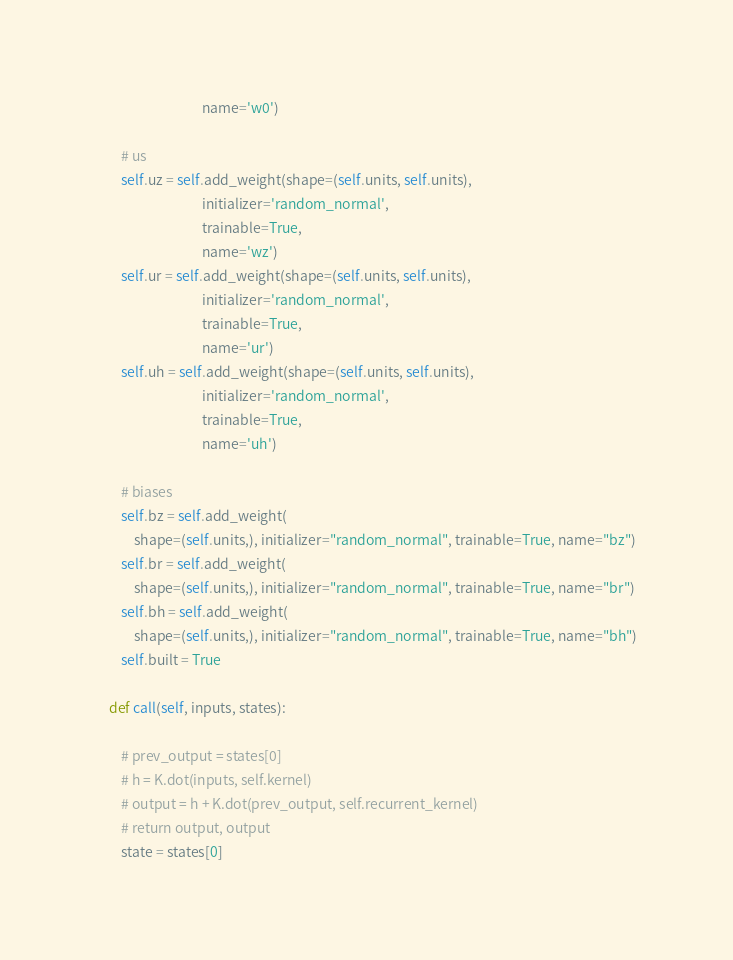Convert code to text. <code><loc_0><loc_0><loc_500><loc_500><_Python_>                                  name='w0')

        # us
        self.uz = self.add_weight(shape=(self.units, self.units),
                                  initializer='random_normal',
                                  trainable=True,
                                  name='wz')
        self.ur = self.add_weight(shape=(self.units, self.units),
                                  initializer='random_normal',
                                  trainable=True,
                                  name='ur')
        self.uh = self.add_weight(shape=(self.units, self.units),
                                  initializer='random_normal',
                                  trainable=True,
                                  name='uh')

        # biases
        self.bz = self.add_weight(
            shape=(self.units,), initializer="random_normal", trainable=True, name="bz")
        self.br = self.add_weight(
            shape=(self.units,), initializer="random_normal", trainable=True, name="br")
        self.bh = self.add_weight(
            shape=(self.units,), initializer="random_normal", trainable=True, name="bh")
        self.built = True

    def call(self, inputs, states):

        # prev_output = states[0]
        # h = K.dot(inputs, self.kernel)
        # output = h + K.dot(prev_output, self.recurrent_kernel)
        # return output, output
        state = states[0]</code> 